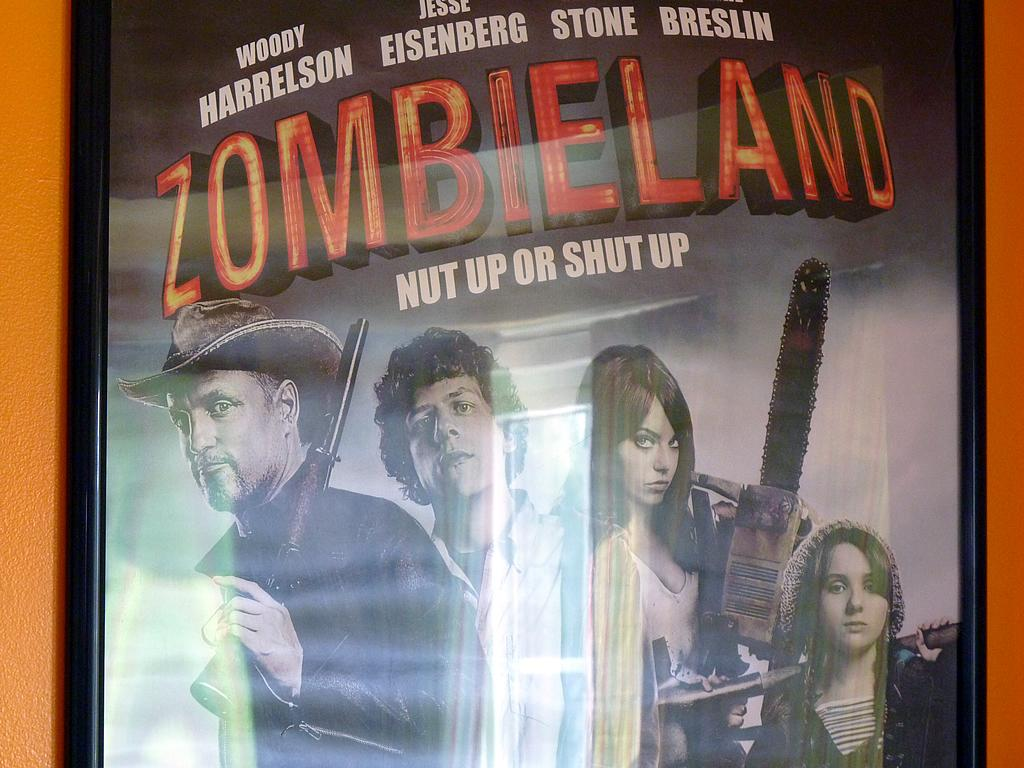What is the main object in the image? There is a board in the image. What is on the board? The board has text and images attached to it. Where is the board located? The board is attached to the wall. What type of street is visible in the image? There is no street visible in the image; it features a board with text and images attached to it. How many faces can be seen on the board in the image? There are no faces present on the board in the image. 